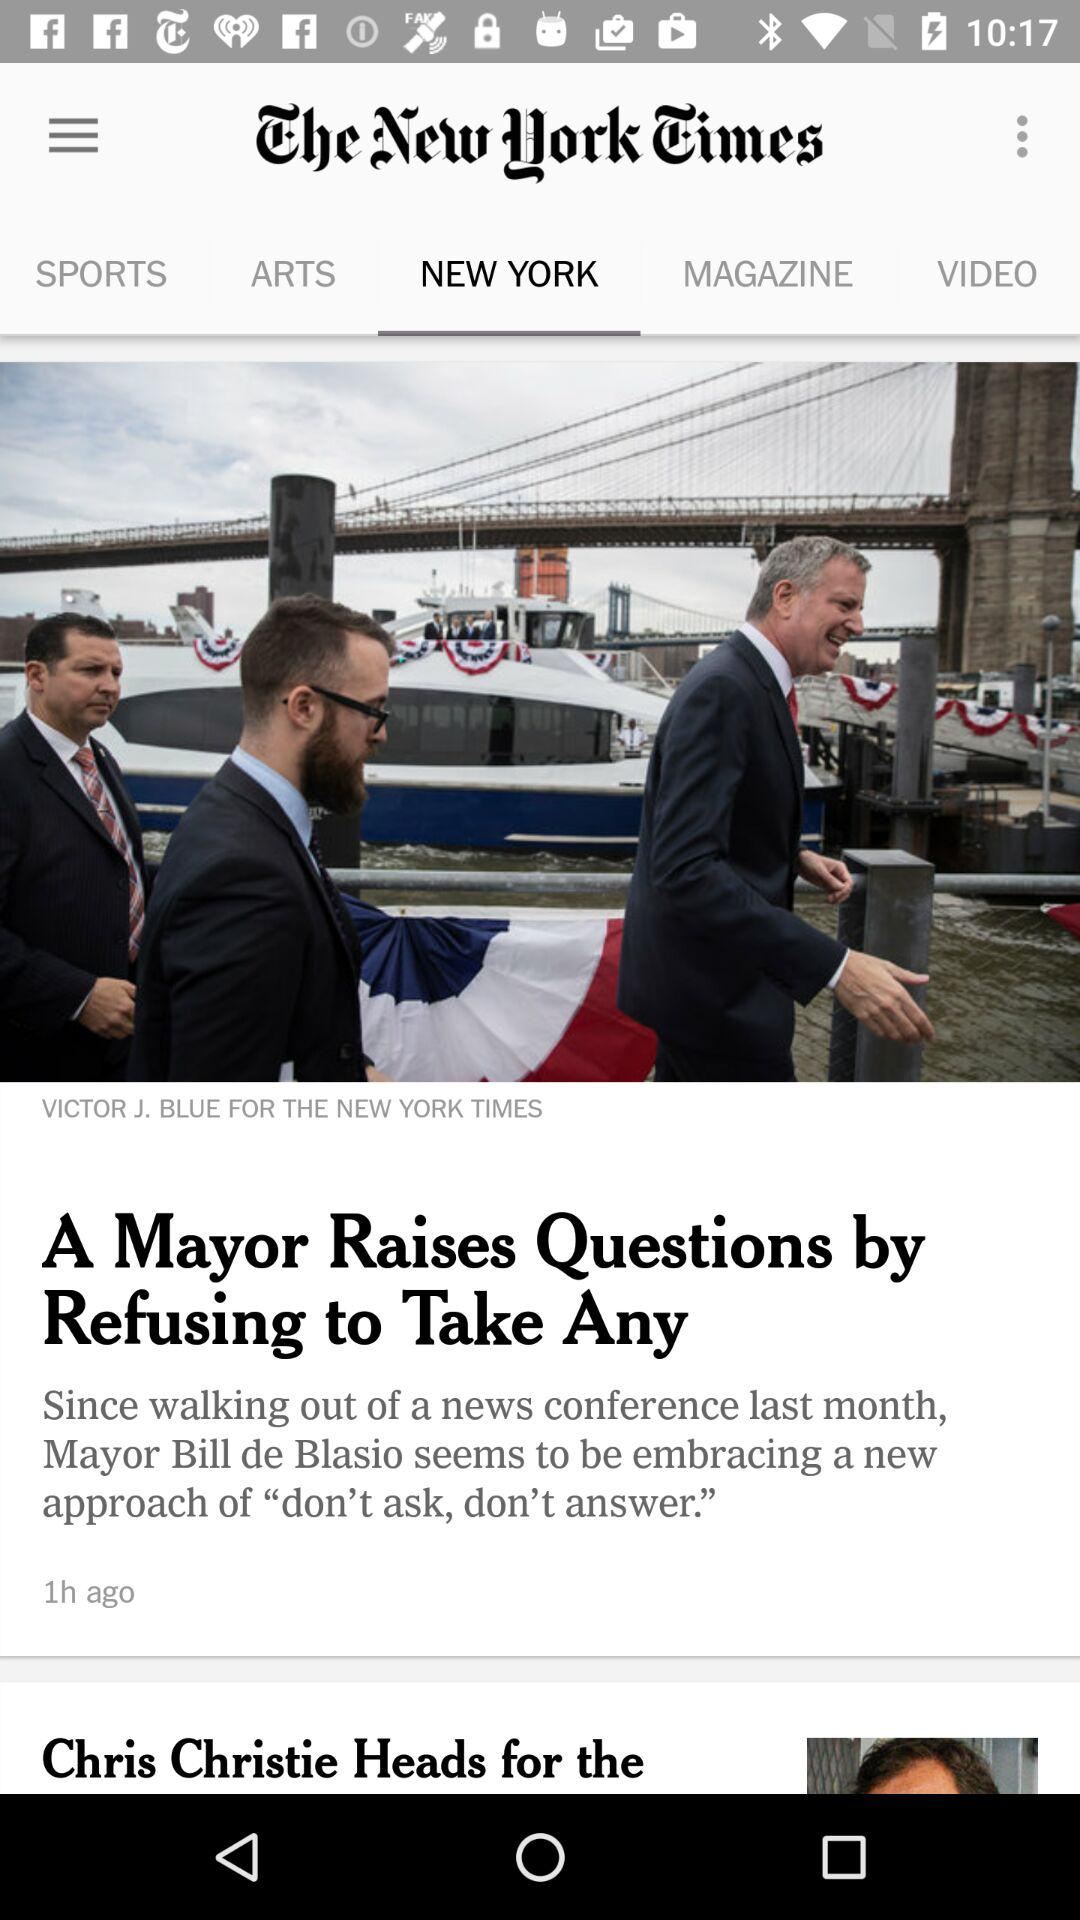When was the news posted? The news was posted 1 hour ago. 